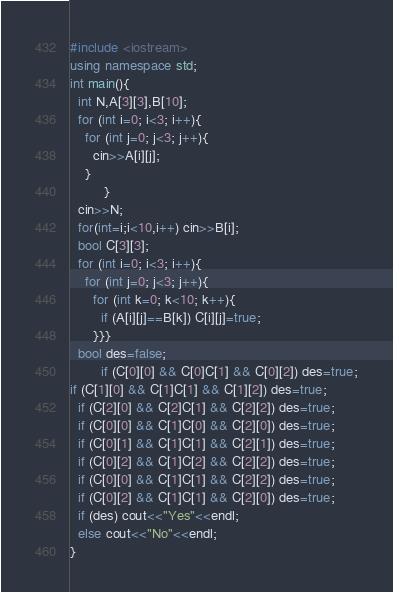<code> <loc_0><loc_0><loc_500><loc_500><_C++_>#include <iostream>
using namespace std;
int main(){
  int N,A[3][3],B[10];
  for (int i=0; i<3; i++){
    for (int j=0; j<3; j++){
      cin>>A[i][j];
    }
         }
  cin>>N;
  for(int=i;i<10,i++) cin>>B[i];
  bool C[3][3];
  for (int i=0; i<3; i++){
    for (int j=0; j<3; j++){
      for (int k=0; k<10; k++){
        if (A[i][j]==B[k]) C[i][j]=true;
      }}}
  bool des=false;
        if (C[0][0] && C[0]C[1] && C[0][2]) des=true;
if (C[1][0] && C[1]C[1] && C[1][2]) des=true;
  if (C[2][0] && C[2]C[1] && C[2][2]) des=true;
  if (C[0][0] && C[1]C[0] && C[2][0]) des=true;
  if (C[0][1] && C[1]C[1] && C[2][1]) des=true;
  if (C[0][2] && C[1]C[2] && C[2][2]) des=true;
  if (C[0][0] && C[1]C[1] && C[2][2]) des=true;
  if (C[0][2] && C[1]C[1] && C[2][0]) des=true;
  if (des) cout<<"Yes"<<endl;
  else cout<<"No"<<endl;
}</code> 